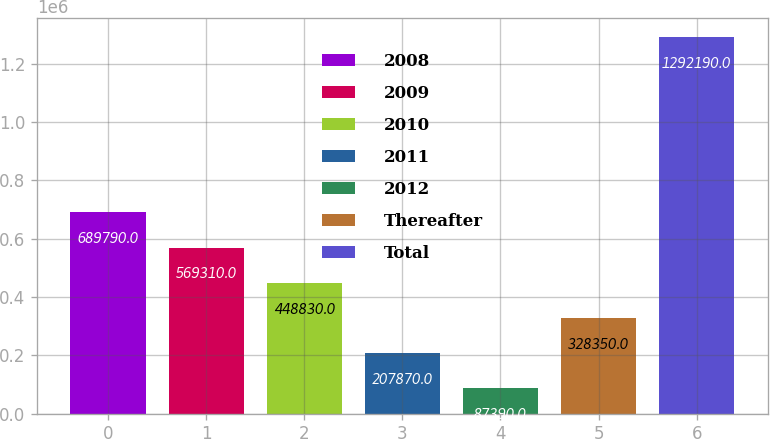<chart> <loc_0><loc_0><loc_500><loc_500><bar_chart><fcel>2008<fcel>2009<fcel>2010<fcel>2011<fcel>2012<fcel>Thereafter<fcel>Total<nl><fcel>689790<fcel>569310<fcel>448830<fcel>207870<fcel>87390<fcel>328350<fcel>1.29219e+06<nl></chart> 